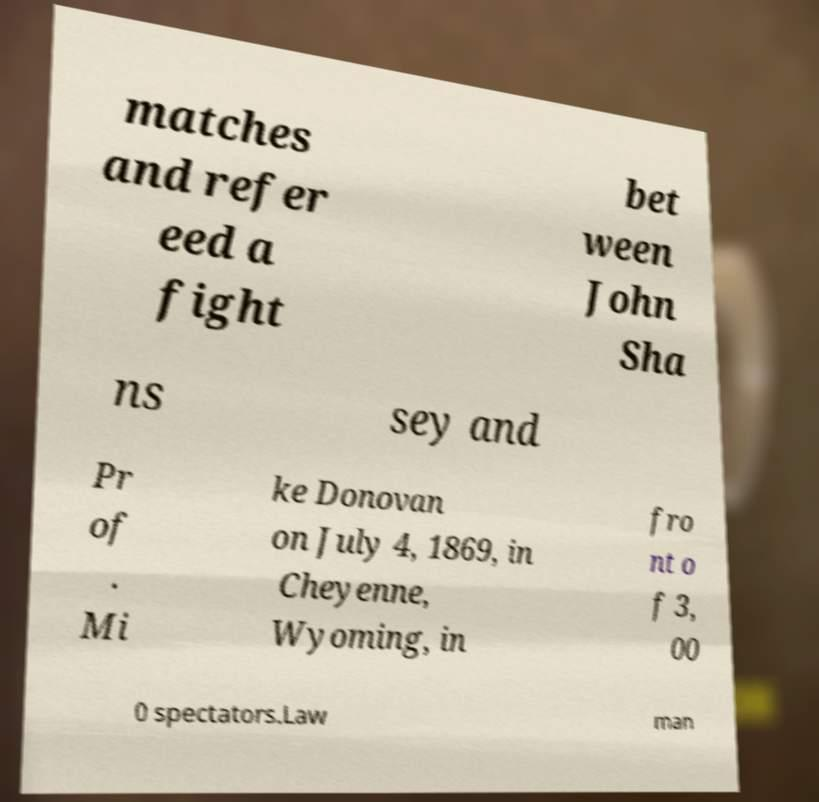Could you extract and type out the text from this image? matches and refer eed a fight bet ween John Sha ns sey and Pr of . Mi ke Donovan on July 4, 1869, in Cheyenne, Wyoming, in fro nt o f 3, 00 0 spectators.Law man 